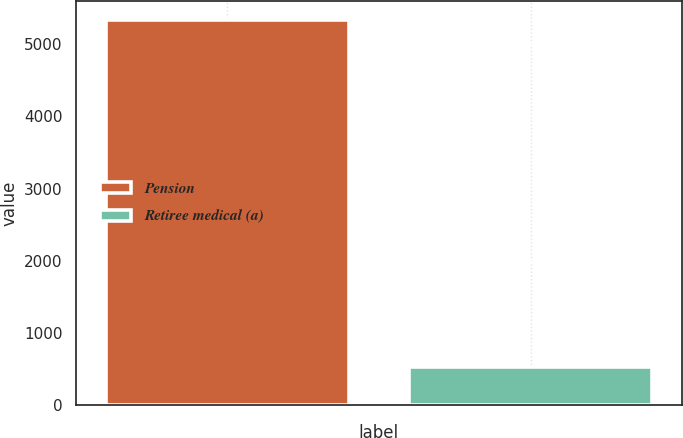<chart> <loc_0><loc_0><loc_500><loc_500><bar_chart><fcel>Pension<fcel>Retiree medical (a)<nl><fcel>5335<fcel>535<nl></chart> 